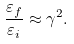Convert formula to latex. <formula><loc_0><loc_0><loc_500><loc_500>\frac { \varepsilon _ { f } } { \varepsilon _ { i } } \approx \gamma ^ { 2 } .</formula> 